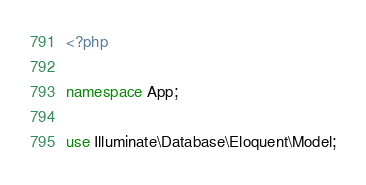<code> <loc_0><loc_0><loc_500><loc_500><_PHP_><?php

namespace App;

use Illuminate\Database\Eloquent\Model;</code> 